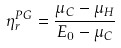<formula> <loc_0><loc_0><loc_500><loc_500>\eta _ { r } ^ { P G } = \frac { \mu _ { C } - \mu _ { H } } { E _ { 0 } - \mu _ { C } }</formula> 